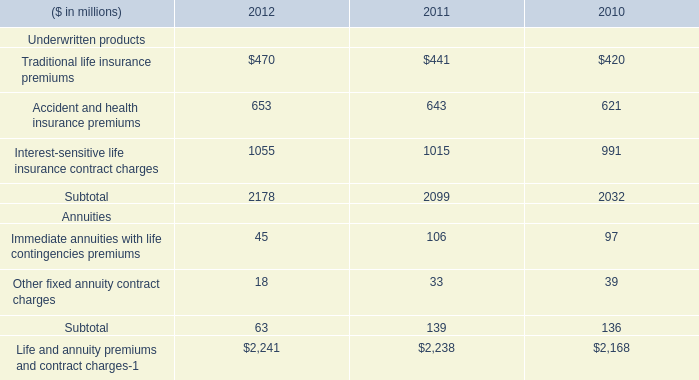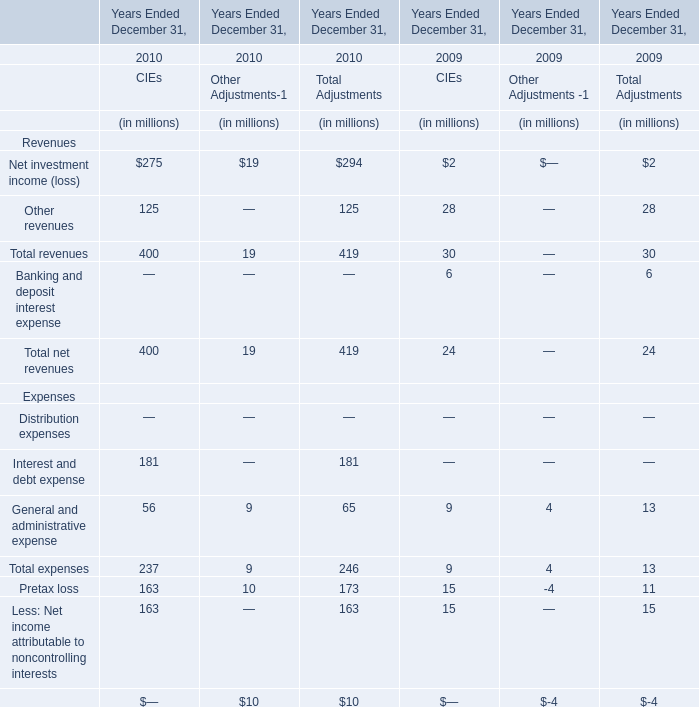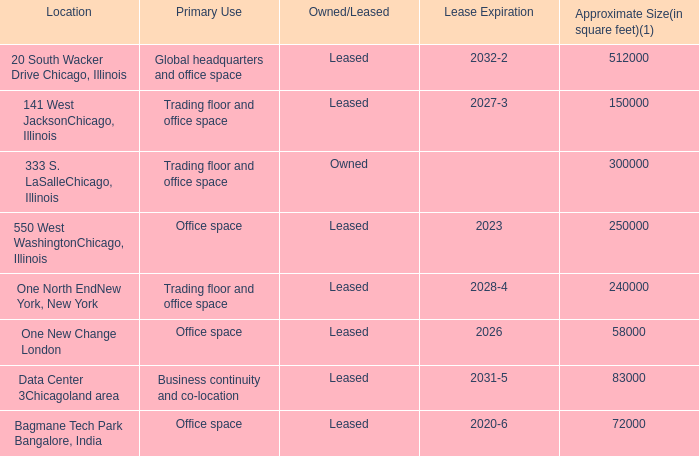What's the average of Life and annuity premiums and contract charges Annuities of 2012, and 550 West WashingtonChicago, Illinois of Lease Expiration ? 
Computations: ((2241.0 + 2023.0) / 2)
Answer: 2132.0. 